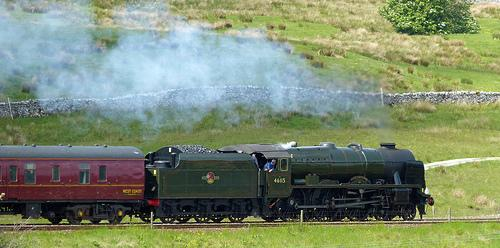What is the color of the first train car and what action is happening around it? The first train car is green and white smoke is coming out from it. How many patches of green grass can you find in the image, and what is the average size of these patches in terms of width and height? There are several patches of green grass with varying sizes, making it difficult to determine an average size accurately without specific measurements. What is the occupation of the person present on the train? The person on the train is the engineer or train operator. What are some unique features of the train in the image that makes it stand out compared to modern trains? The train has large wheels, a short smoke stack, and a coal car which make it stand out compared to modern trains. What is the color and material of the wall in the background, and what is on the other side of it? The wall is made of gray and brown stone, and there is grass on the other side of it. Enumerate the colors of the train cars in order, along with the main object present in each car. Green engine with white smoke, red passenger car with windows and a line of people. What kind of landscape surrounds the train and the wall? A grassy hill and field with patches of green grass surround the train and the stone wall. Describe the overall atmosphere of the image, considering the train, its surroundings, and the background. The image has a nostalgic and peaceful atmosphere, featuring an old train traveling through a picturesque landscape with a stone wall and green grassy hills. Mention two essential features of the train's appearance that might indicate that it is old. The train has a short smoke stack and large wheels, which might indicate that it is old. What is the train doing, and what color are the tracks under it? The train is chugging down the track, and the tracks are gray. 